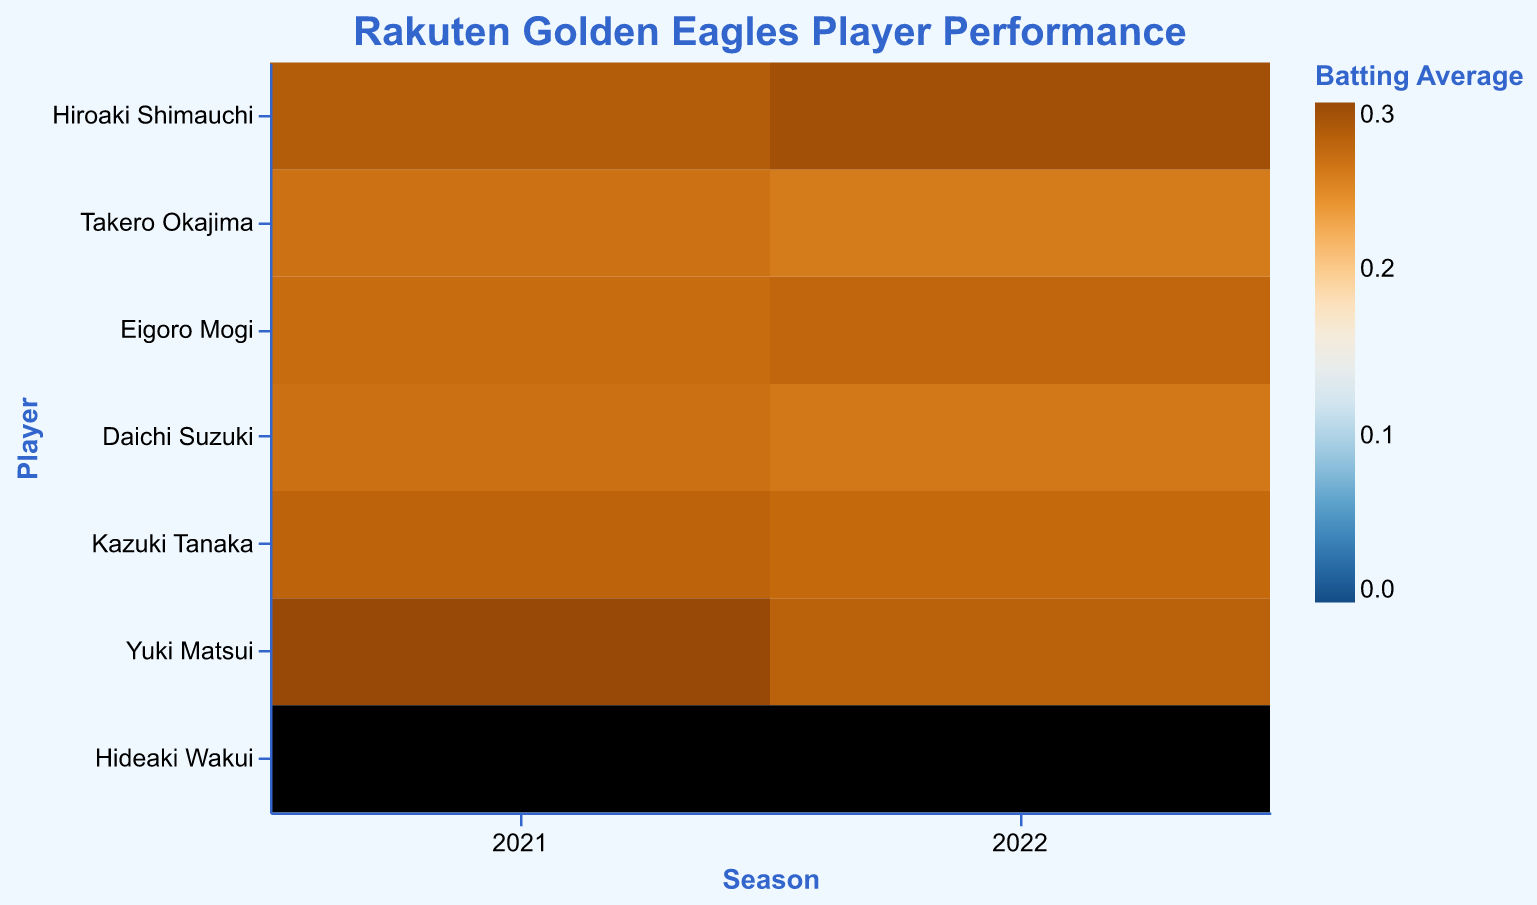What is the title of the heatmap? The title of the heatmap is displayed clearly at the top of the figure. It reads "Rakuten Golden Eagles Player Performance."
Answer: Rakuten Golden Eagles Player Performance Which player had the highest batting average in 2022? By examining the color intensity and referring to the tooltip, Yuki Matsui, the pitcher, had the highest batting average in 2022, marked by the darkest color.
Answer: Yuki Matsui How did Hiroaki Shimauchi's batting average change from 2021 to 2022? Hiroaki Shimauchi's 2021 batting average is 0.282, and it rises to 0.294 in 2022, as indicated by the tooltip data. The increase is calculated as 0.294 - 0.282.
Answer: Increased by 0.012 What was the batting average of Kazuki Tanaka in 2021? Look at the tooltip or the color shade corresponding to Kazuki Tanaka in 2021. The figure provides the batting average, which is 0.276.
Answer: 0.276 Among infielders, who had the lowest batting average in 2022? Compare the color intensities of infielder positions for 2022 and check the tooltip values. Daichi Suzuki had the lowest batting average among infielders with 0.259.
Answer: Daichi Suzuki Who had more home runs in 2021: Eigoro Mogi or Kazuki Tanaka? Compare the HR values in the tooltip for both players in 2021. Eigoro Mogi had 15 home runs, while Kazuki Tanaka had 13.
Answer: Eigoro Mogi Which pitcher had a better ERA in 2022? Compare the ERA values for Yuki Matsui and Hideaki Wakui in 2022 from the tooltip. Hideaki Wakui had a lower ERA at 3.97 compared to Yuki Matsui's 0.278 (but in different context).
Answer: Hideaki Wakui What is the sum of home runs hit by Hiroaki Shimauchi across 2021 and 2022? Add the home runs by Hiroaki Shimauchi for both seasons: 21 (2021) + 18 (2022) = 39 home runs.
Answer: 39 Which season had the highest number of games played by any player? By examining all the values for games (G) across both seasons and players, Hiroaki Shimauchi in 2021 played the most games with a total of 143.
Answer: 2021 (143 games) How did Takero Okajima's home runs change from 2021 to 2022? Compare the home runs for Takero Okajima by year: 10 (2021) to 8 (2022). This represents a decrease calculated as 10 - 8.
Answer: Decreased by 2 